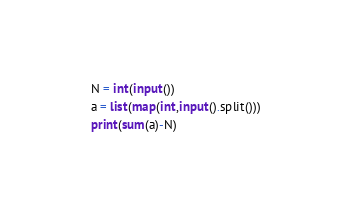Convert code to text. <code><loc_0><loc_0><loc_500><loc_500><_Python_>N = int(input())
a = list(map(int,input().split()))
print(sum(a)-N)</code> 